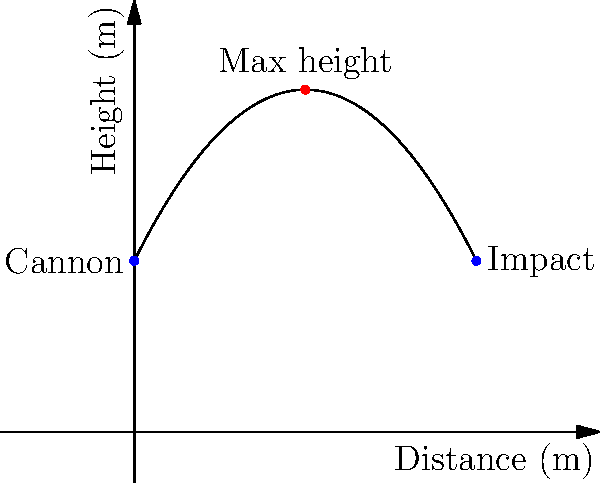As a war historian studying artillery tactics, you're analyzing the trajectory of a cannonball fired during the Siege of Vienna in 1683. The path of the cannonball can be modeled by the function $h(x) = -0.1x^2 + 2x + 10$, where $h$ is the height in meters and $x$ is the horizontal distance in meters. What is the maximum height reached by the cannonball during its flight? To find the maximum height of the cannonball's trajectory, we need to follow these steps:

1) The function $h(x) = -0.1x^2 + 2x + 10$ is a quadratic function, which forms a parabola.

2) The maximum height occurs at the vertex of this parabola.

3) For a quadratic function in the form $f(x) = ax^2 + bx + c$, the x-coordinate of the vertex is given by $x = -\frac{b}{2a}$.

4) In our case, $a = -0.1$ and $b = 2$. So:

   $x = -\frac{2}{2(-0.1)} = -\frac{2}{-0.2} = 10$

5) To find the maximum height, we need to calculate $h(10)$:

   $h(10) = -0.1(10)^2 + 2(10) + 10$
   $= -0.1(100) + 20 + 10$
   $= -10 + 20 + 10$
   $= 20$

Therefore, the maximum height reached by the cannonball is 20 meters.
Answer: 20 meters 